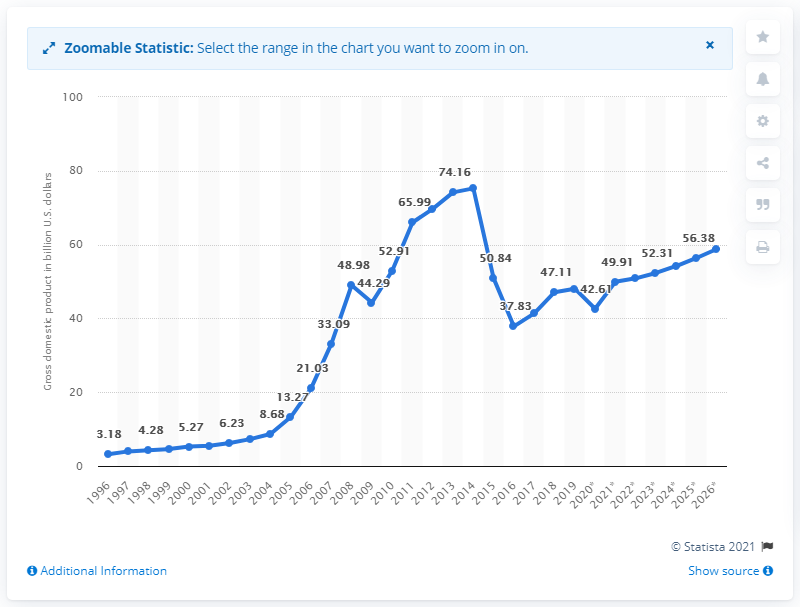Give some essential details in this illustration. In 2019, Azerbaijan's gross domestic product was 48.05. 